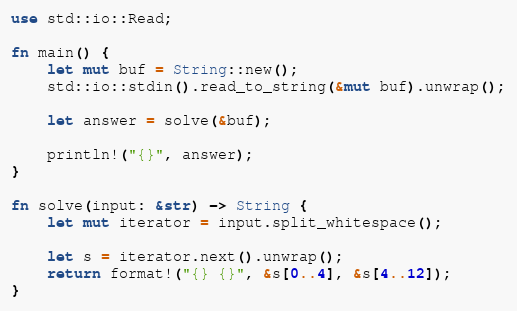<code> <loc_0><loc_0><loc_500><loc_500><_Rust_>use std::io::Read;

fn main() {
    let mut buf = String::new();
    std::io::stdin().read_to_string(&mut buf).unwrap();

    let answer = solve(&buf);

    println!("{}", answer);
}

fn solve(input: &str) -> String {
    let mut iterator = input.split_whitespace();

    let s = iterator.next().unwrap();
    return format!("{} {}", &s[0..4], &s[4..12]);
}
</code> 